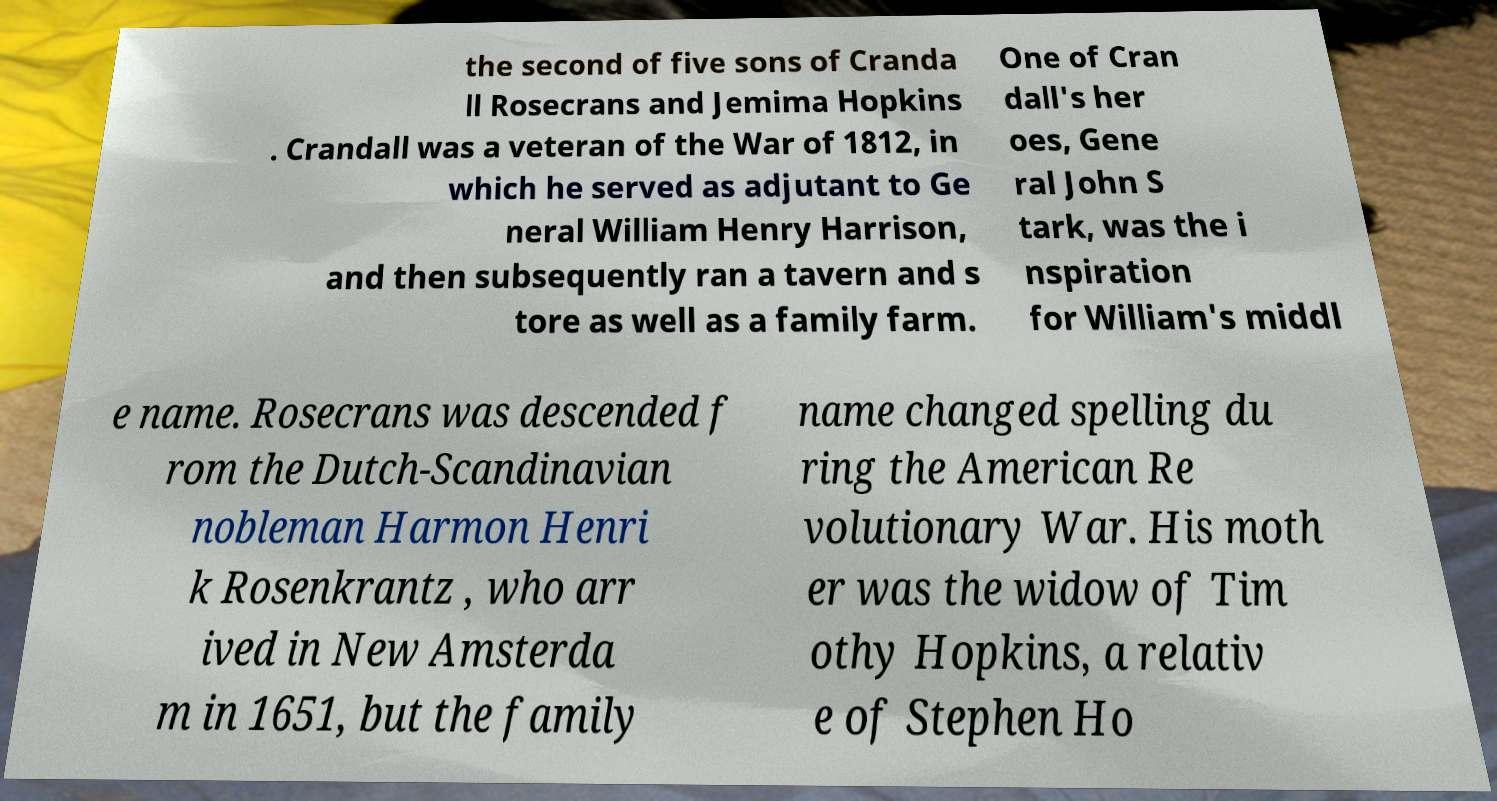Please identify and transcribe the text found in this image. the second of five sons of Cranda ll Rosecrans and Jemima Hopkins . Crandall was a veteran of the War of 1812, in which he served as adjutant to Ge neral William Henry Harrison, and then subsequently ran a tavern and s tore as well as a family farm. One of Cran dall's her oes, Gene ral John S tark, was the i nspiration for William's middl e name. Rosecrans was descended f rom the Dutch-Scandinavian nobleman Harmon Henri k Rosenkrantz , who arr ived in New Amsterda m in 1651, but the family name changed spelling du ring the American Re volutionary War. His moth er was the widow of Tim othy Hopkins, a relativ e of Stephen Ho 